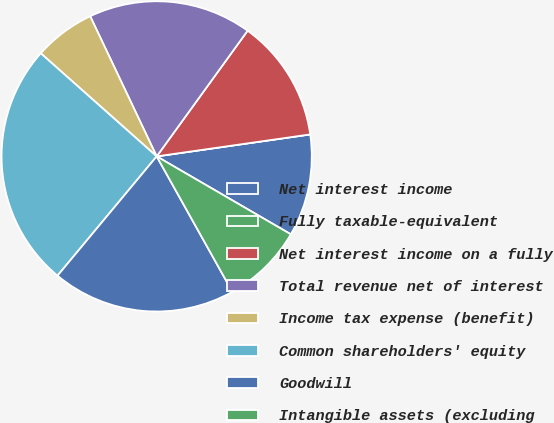Convert chart. <chart><loc_0><loc_0><loc_500><loc_500><pie_chart><fcel>Net interest income<fcel>Fully taxable-equivalent<fcel>Net interest income on a fully<fcel>Total revenue net of interest<fcel>Income tax expense (benefit)<fcel>Common shareholders' equity<fcel>Goodwill<fcel>Intangible assets (excluding<nl><fcel>10.64%<fcel>0.0%<fcel>12.77%<fcel>17.02%<fcel>6.38%<fcel>25.53%<fcel>19.15%<fcel>8.51%<nl></chart> 